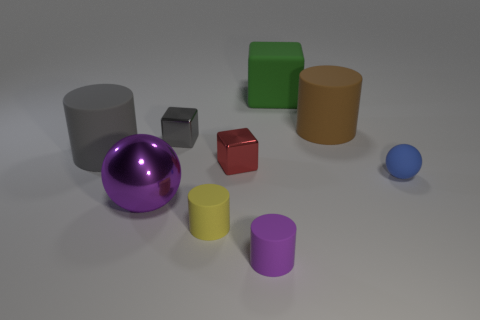Subtract all cylinders. How many objects are left? 5 Subtract 3 cubes. How many cubes are left? 0 Subtract all blue cylinders. Subtract all yellow spheres. How many cylinders are left? 4 Subtract all purple spheres. How many green blocks are left? 1 Subtract all small blue cylinders. Subtract all blue things. How many objects are left? 8 Add 6 big gray cylinders. How many big gray cylinders are left? 7 Add 3 big objects. How many big objects exist? 7 Add 1 small yellow rubber things. How many objects exist? 10 Subtract all blue balls. How many balls are left? 1 Subtract all shiny cubes. How many cubes are left? 1 